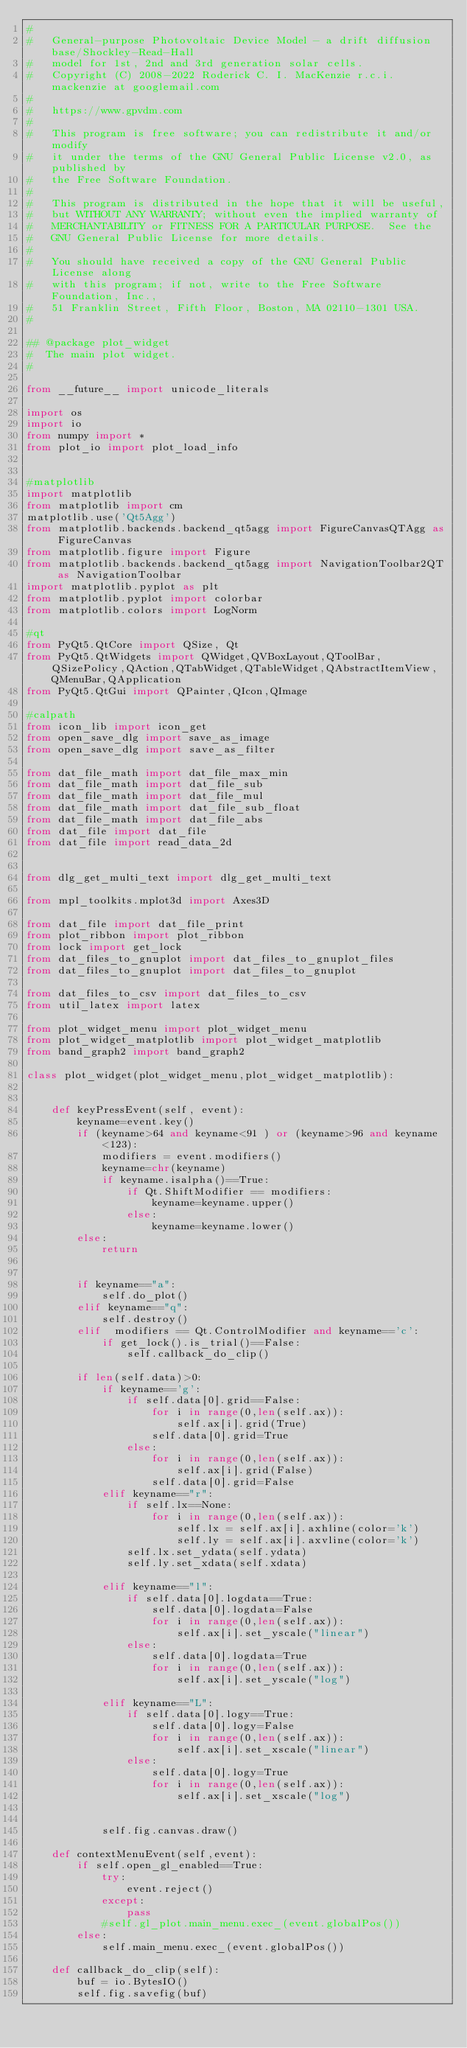Convert code to text. <code><loc_0><loc_0><loc_500><loc_500><_Python_># 
#   General-purpose Photovoltaic Device Model - a drift diffusion base/Shockley-Read-Hall
#   model for 1st, 2nd and 3rd generation solar cells.
#   Copyright (C) 2008-2022 Roderick C. I. MacKenzie r.c.i.mackenzie at googlemail.com
#   
#   https://www.gpvdm.com
#   
#   This program is free software; you can redistribute it and/or modify
#   it under the terms of the GNU General Public License v2.0, as published by
#   the Free Software Foundation.
#   
#   This program is distributed in the hope that it will be useful,
#   but WITHOUT ANY WARRANTY; without even the implied warranty of
#   MERCHANTABILITY or FITNESS FOR A PARTICULAR PURPOSE.  See the
#   GNU General Public License for more details.
#   
#   You should have received a copy of the GNU General Public License along
#   with this program; if not, write to the Free Software Foundation, Inc.,
#   51 Franklin Street, Fifth Floor, Boston, MA 02110-1301 USA.
#   

## @package plot_widget
#  The main plot widget.
#

from __future__ import unicode_literals

import os
import io
from numpy import *
from plot_io import plot_load_info


#matplotlib
import matplotlib
from matplotlib import cm
matplotlib.use('Qt5Agg')
from matplotlib.backends.backend_qt5agg import FigureCanvasQTAgg as FigureCanvas
from matplotlib.figure import Figure
from matplotlib.backends.backend_qt5agg import NavigationToolbar2QT as NavigationToolbar
import matplotlib.pyplot as plt
from matplotlib.pyplot import colorbar
from matplotlib.colors import LogNorm

#qt
from PyQt5.QtCore import QSize, Qt 
from PyQt5.QtWidgets import QWidget,QVBoxLayout,QToolBar,QSizePolicy,QAction,QTabWidget,QTableWidget,QAbstractItemView, QMenuBar,QApplication
from PyQt5.QtGui import QPainter,QIcon,QImage

#calpath
from icon_lib import icon_get
from open_save_dlg import save_as_image
from open_save_dlg import save_as_filter

from dat_file_math import dat_file_max_min
from dat_file_math import dat_file_sub
from dat_file_math import dat_file_mul
from dat_file_math import dat_file_sub_float
from dat_file_math import dat_file_abs
from dat_file import dat_file
from dat_file import read_data_2d


from dlg_get_multi_text import dlg_get_multi_text

from mpl_toolkits.mplot3d import Axes3D

from dat_file import dat_file_print
from plot_ribbon import plot_ribbon
from lock import get_lock
from dat_files_to_gnuplot import dat_files_to_gnuplot_files
from dat_files_to_gnuplot import dat_files_to_gnuplot

from dat_files_to_csv import dat_files_to_csv
from util_latex import latex

from plot_widget_menu import plot_widget_menu
from plot_widget_matplotlib import plot_widget_matplotlib
from band_graph2 import band_graph2

class plot_widget(plot_widget_menu,plot_widget_matplotlib):


	def keyPressEvent(self, event):
		keyname=event.key()
		if (keyname>64 and keyname<91 ) or (keyname>96 and keyname<123):
			modifiers = event.modifiers()
			keyname=chr(keyname)
			if keyname.isalpha()==True:
				if Qt.ShiftModifier == modifiers:
					keyname=keyname.upper()
				else:
					keyname=keyname.lower()
		else:
			return


		if keyname=="a":
			self.do_plot()
		elif keyname=="q":
			self.destroy()
		elif  modifiers == Qt.ControlModifier and keyname=='c':
			if get_lock().is_trial()==False:
				self.callback_do_clip()

		if len(self.data)>0:
			if keyname=='g':
				if self.data[0].grid==False:
					for i in range(0,len(self.ax)):
						self.ax[i].grid(True)
					self.data[0].grid=True
				else:
					for i in range(0,len(self.ax)):
						self.ax[i].grid(False)
					self.data[0].grid=False
			elif keyname=="r":
				if self.lx==None:
					for i in range(0,len(self.ax)):
						self.lx = self.ax[i].axhline(color='k')
						self.ly = self.ax[i].axvline(color='k')
				self.lx.set_ydata(self.ydata)
				self.ly.set_xdata(self.xdata)

			elif keyname=="l":
				if self.data[0].logdata==True:
					self.data[0].logdata=False
					for i in range(0,len(self.ax)):
						self.ax[i].set_yscale("linear")
				else:
					self.data[0].logdata=True
					for i in range(0,len(self.ax)):
						self.ax[i].set_yscale("log")

			elif keyname=="L":
				if self.data[0].logy==True:
					self.data[0].logy=False
					for i in range(0,len(self.ax)):
						self.ax[i].set_xscale("linear")
				else:
					self.data[0].logy=True
					for i in range(0,len(self.ax)):
						self.ax[i].set_xscale("log")


			self.fig.canvas.draw()

	def contextMenuEvent(self,event):
		if self.open_gl_enabled==True:
			try:
				event.reject()
			except:
				pass
			#self.gl_plot.main_menu.exec_(event.globalPos())
		else:
			self.main_menu.exec_(event.globalPos())

	def callback_do_clip(self):
		buf = io.BytesIO()
		self.fig.savefig(buf)</code> 